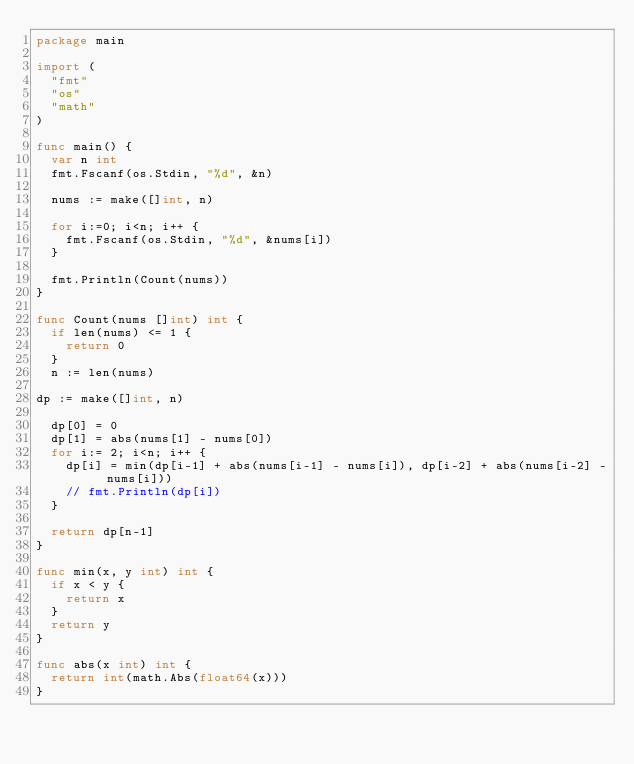Convert code to text. <code><loc_0><loc_0><loc_500><loc_500><_Go_>package main

import (
	"fmt"
	"os"
	"math"
)

func main() {
  var n int
  fmt.Fscanf(os.Stdin, "%d", &n)
  
  nums := make([]int, n)
  
  for i:=0; i<n; i++ {
    fmt.Fscanf(os.Stdin, "%d", &nums[i])
  }
  
  fmt.Println(Count(nums))
}

func Count(nums []int) int {
  if len(nums) <= 1 {
    return 0
  }
  n := len(nums)
  
dp := make([]int, n)

	dp[0] = 0
	dp[1] = abs(nums[1] - nums[0])
  for i:= 2; i<n; i++ {
	  dp[i] = min(dp[i-1] + abs(nums[i-1] - nums[i]), dp[i-2] + abs(nums[i-2] - nums[i]))
	  // fmt.Println(dp[i])
  }
	
  return dp[n-1]
}

func min(x, y int) int {
  if x < y {
    return x
  }
  return y
}

func abs(x int) int {
	return int(math.Abs(float64(x)))
}
</code> 